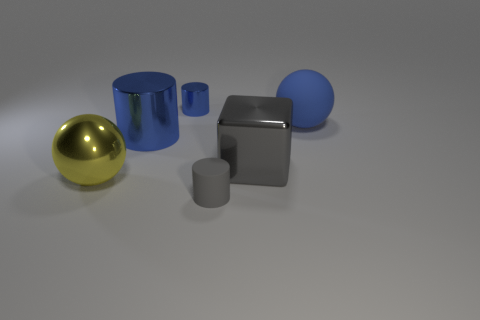Add 2 big yellow metal objects. How many objects exist? 8 Subtract all blocks. How many objects are left? 5 Add 5 big gray blocks. How many big gray blocks exist? 6 Subtract 0 red spheres. How many objects are left? 6 Subtract all large yellow metal balls. Subtract all tiny blue objects. How many objects are left? 4 Add 3 small gray matte cylinders. How many small gray matte cylinders are left? 4 